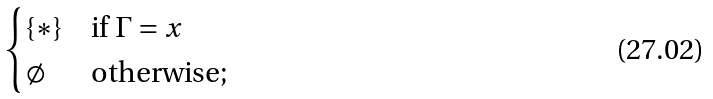Convert formula to latex. <formula><loc_0><loc_0><loc_500><loc_500>\begin{cases} \{ \ast \} & \text {if $\Gamma = x$} \\ \emptyset & \text {otherwise;} \end{cases}</formula> 